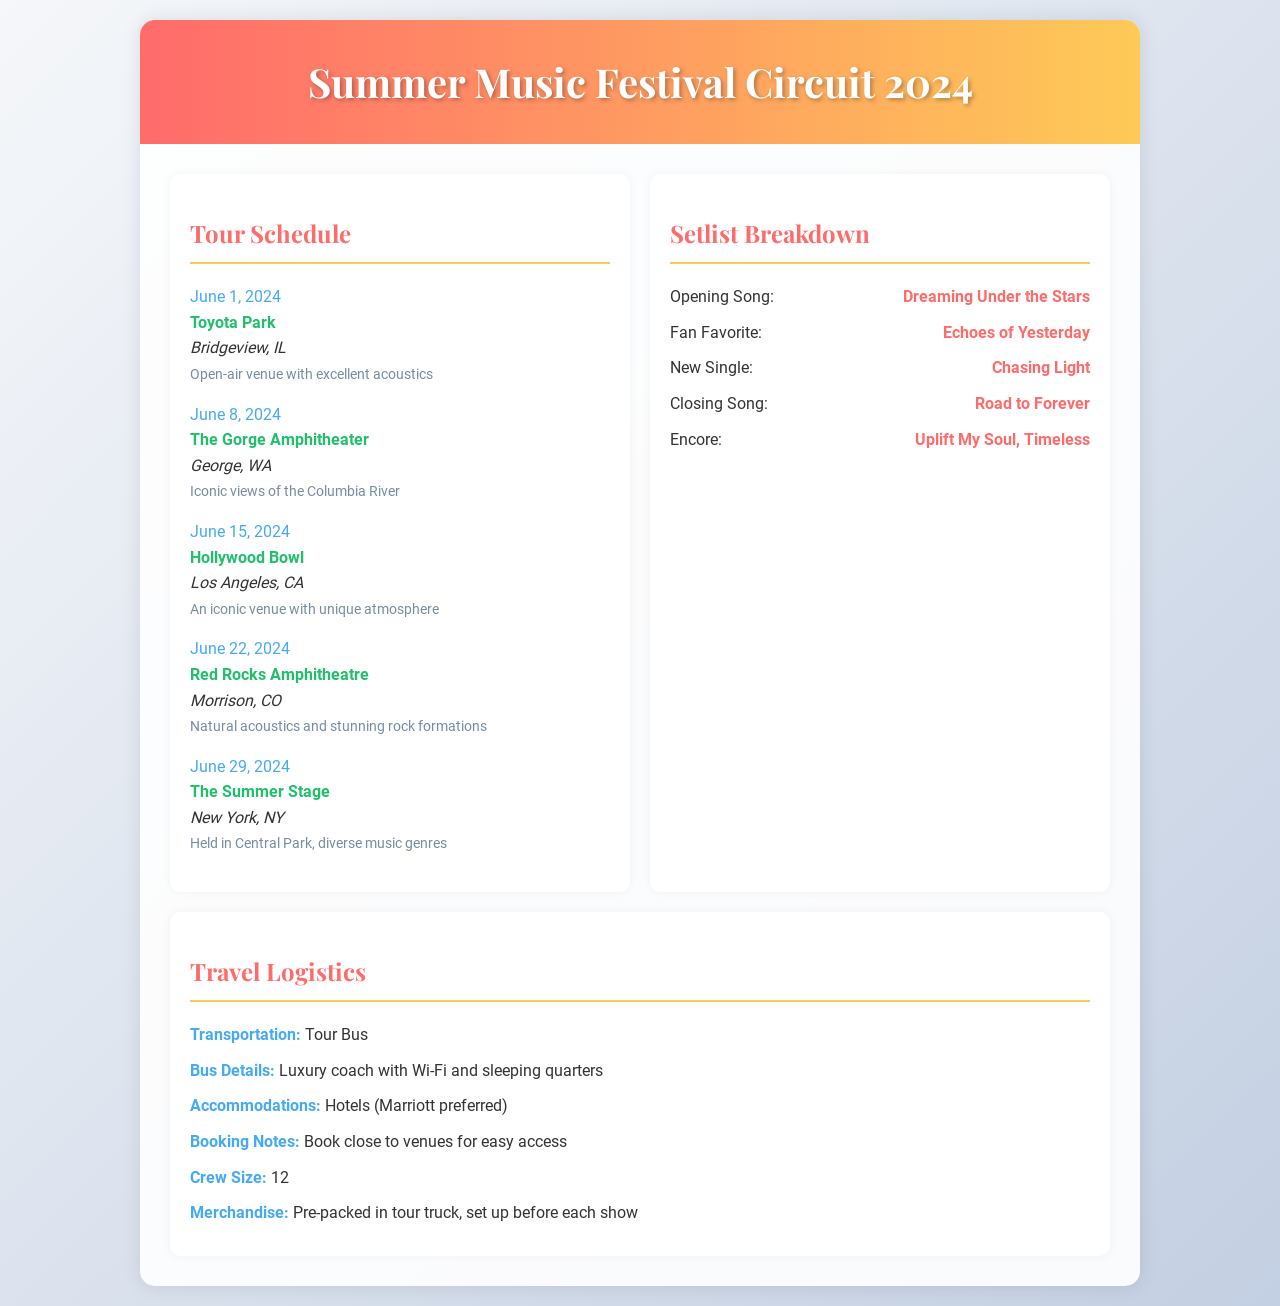What is the venue for June 8, 2024? The venue for June 8, 2024, is specified in the schedule section as The Gorge Amphitheater.
Answer: The Gorge Amphitheater What is the date of the performance at Hollywood Bowl? The date of the performance at Hollywood Bowl is clearly stated in the schedule section.
Answer: June 15, 2024 What is the notable feature of The Summer Stage in New York, NY? The notable feature is mentioned as being held in Central Park with diverse music genres.
Answer: Held in Central Park, diverse music genres What is the closing song of the setlist? The closing song is listed in the setlist breakdown under 'Closing Song.'
Answer: Road to Forever What type of transportation is used for the tour? The transportation type is mentioned under the travel logistics section.
Answer: Tour Bus How many crew members are on the tour? The crew size is provided in the logistics section of the document.
Answer: 12 Which song is the new single featured in the setlist? The new single is specifically labeled in the setlist breakdown.
Answer: Chasing Light What accommodations are preferred for the tour? The preferred accommodations are detailed in the travel logistics.
Answer: Hotels (Marriott preferred) What are the bus details mentioned in the document? The bus details are specified in the logistics section, indicating the features of the tour bus.
Answer: Luxury coach with Wi-Fi and sleeping quarters 